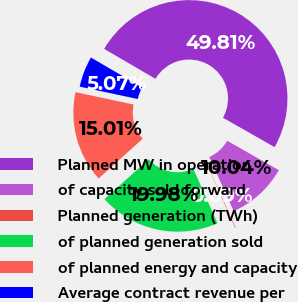<chart> <loc_0><loc_0><loc_500><loc_500><pie_chart><fcel>Planned MW in operation<fcel>of capacity sold forward<fcel>Planned generation (TWh)<fcel>of planned generation sold<fcel>of planned energy and capacity<fcel>Average contract revenue per<nl><fcel>49.81%<fcel>10.04%<fcel>0.09%<fcel>19.98%<fcel>15.01%<fcel>5.07%<nl></chart> 